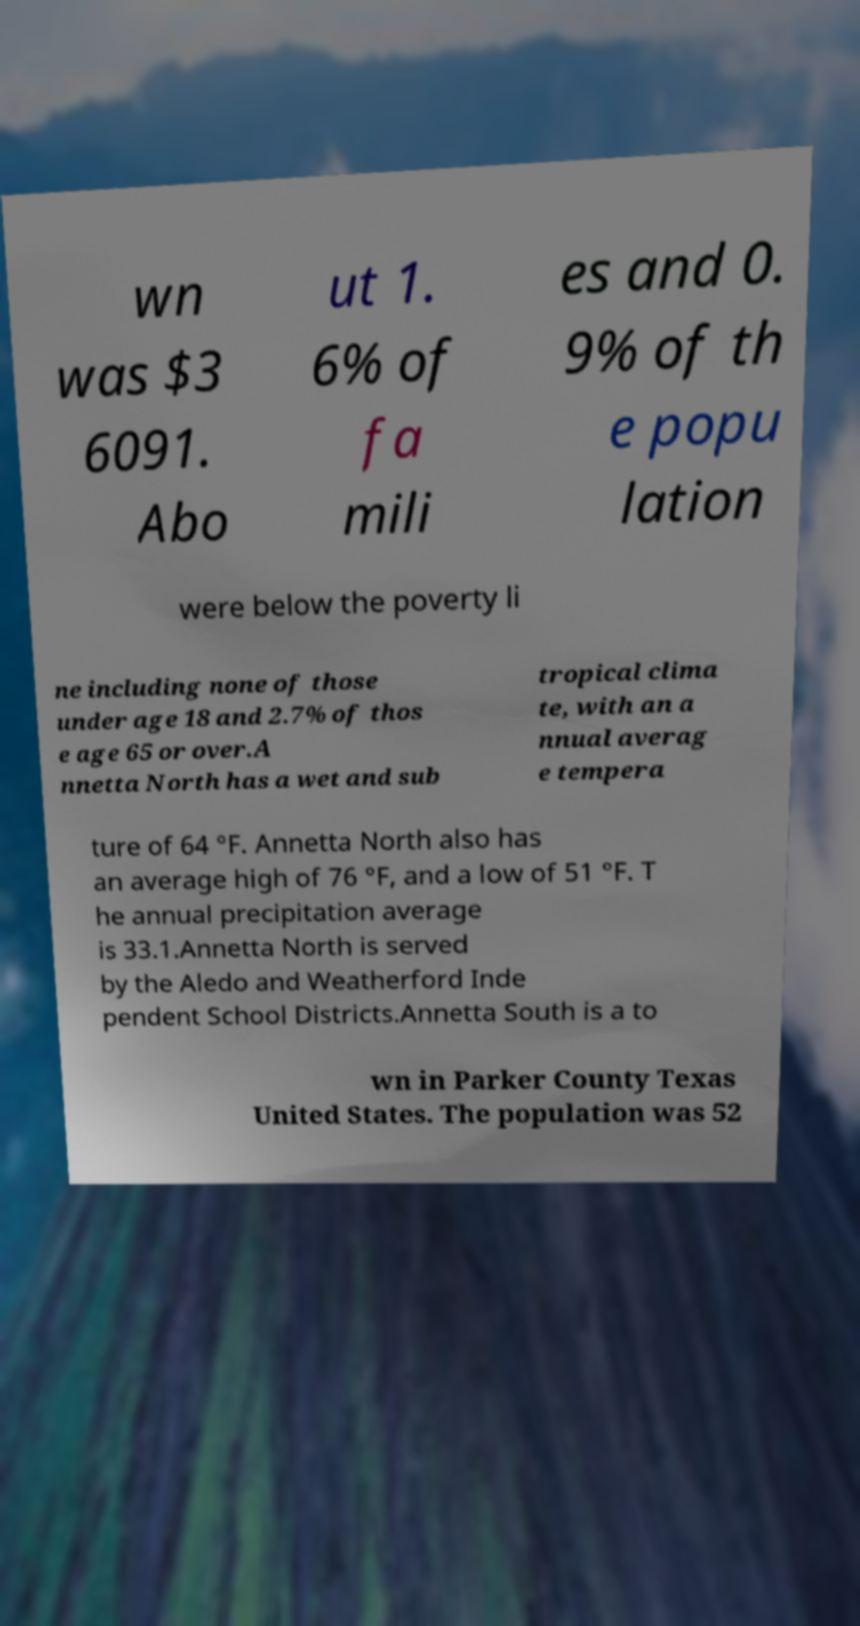Please identify and transcribe the text found in this image. wn was $3 6091. Abo ut 1. 6% of fa mili es and 0. 9% of th e popu lation were below the poverty li ne including none of those under age 18 and 2.7% of thos e age 65 or over.A nnetta North has a wet and sub tropical clima te, with an a nnual averag e tempera ture of 64 °F. Annetta North also has an average high of 76 °F, and a low of 51 °F. T he annual precipitation average is 33.1.Annetta North is served by the Aledo and Weatherford Inde pendent School Districts.Annetta South is a to wn in Parker County Texas United States. The population was 52 